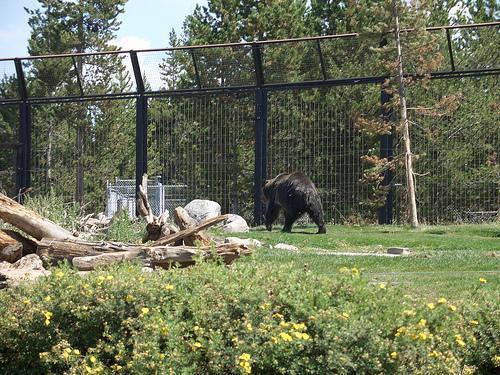How many animals do you see?
Give a very brief answer. 1. 